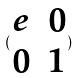<formula> <loc_0><loc_0><loc_500><loc_500>( \begin{matrix} e & 0 \\ 0 & 1 \end{matrix} )</formula> 